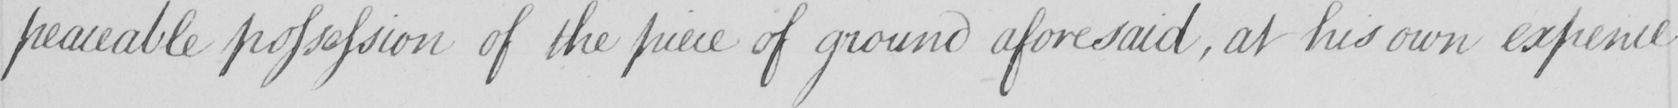Please transcribe the handwritten text in this image. peaceable possession of the piece of ground aforesaid , at his own expence 